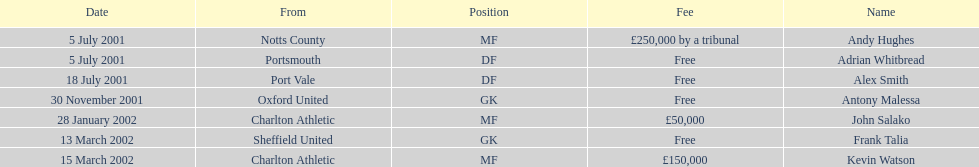Who transferred before 1 august 2001? Andy Hughes, Adrian Whitbread, Alex Smith. Can you give me this table as a dict? {'header': ['Date', 'From', 'Position', 'Fee', 'Name'], 'rows': [['5 July 2001', 'Notts County', 'MF', '£250,000 by a tribunal', 'Andy Hughes'], ['5 July 2001', 'Portsmouth', 'DF', 'Free', 'Adrian Whitbread'], ['18 July 2001', 'Port Vale', 'DF', 'Free', 'Alex Smith'], ['30 November 2001', 'Oxford United', 'GK', 'Free', 'Antony Malessa'], ['28 January 2002', 'Charlton Athletic', 'MF', '£50,000', 'John Salako'], ['13 March 2002', 'Sheffield United', 'GK', 'Free', 'Frank Talia'], ['15 March 2002', 'Charlton Athletic', 'MF', '£150,000', 'Kevin Watson']]} 